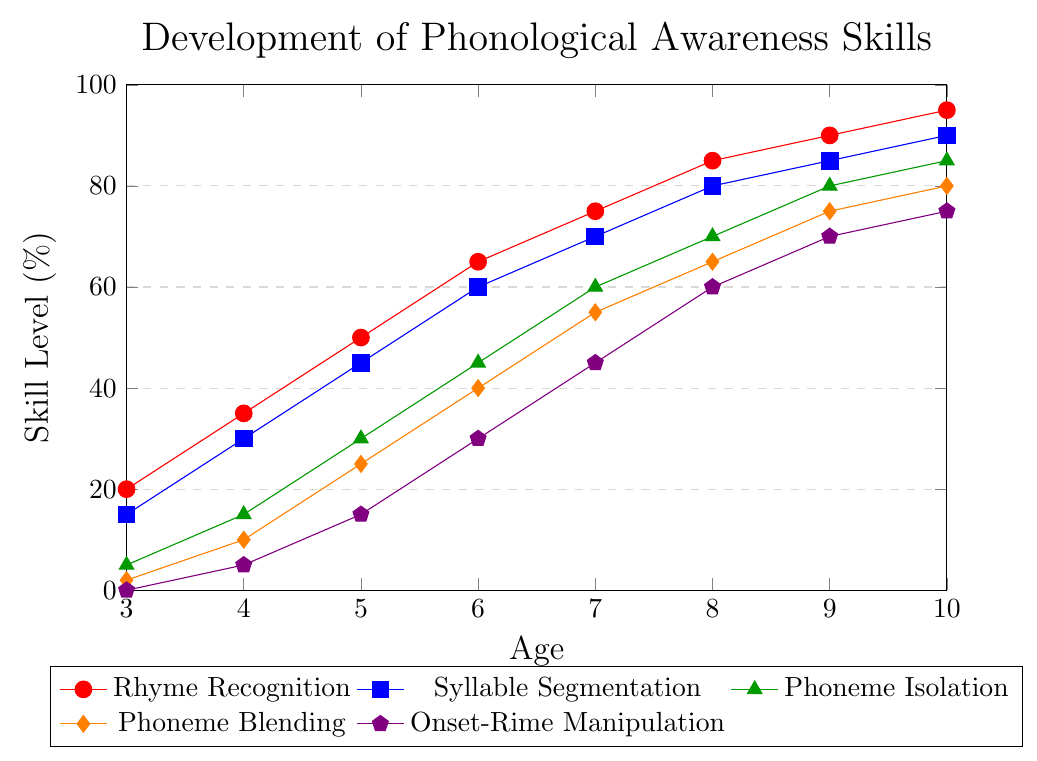What age group shows an 80% skill level for Syllable Segmentation? At age 9, the Syllable Segmentation skill level reaches 85%, but by age 8 it is at 80%. Hence, age 8 is the correct age group.
Answer: 8 Which skill has the lowest percentage at age 3? The data show that Onset-Rime Manipulation has a level of 0% at age 3, which is the lowest among all skills.
Answer: Onset-Rime Manipulation By how much does Phoneme Blending increase from age 4 to age 7? At age 4, the Phoneme Blending level is 10%, and at age 7, it is 55%. The increase is calculated as 55% - 10% = 45%.
Answer: 45% Is the skill level of Phoneme Isolation at age 5 higher than the skill level of Syllable Segmentation at age 4? At age 5, Phoneme Isolation has a skill level of 30% while Syllable Segmentation at age 4 is 30%. Therefore, they are equal.
Answer: No, they are equal What is the average skill level of Rhyme Recognition from ages 6 to 9 inclusive? To find the average, sum the percentages at ages 6, 7, 8, and 9: 65 + 75 + 85 + 90 = 315. Then, divide by the number of ages, which is 4: 315 / 4 = 78.75%.
Answer: 78.75% Among all skill categories, which one reaches 60% first and at what age? Phoneme Isolation reaches 60% at age 7. Other skills reach 60% at age 6 or later.
Answer: Phoneme Isolation at age 7 What is the difference between the skill levels of Rhyme Recognition and Onset-Rime Manipulation at age 10? At age 10, Rhyme Recognition is at 95% and Onset-Rime Manipulation is at 75%. The difference is 95% - 75% = 20%.
Answer: 20% Which skill shows the greatest overall improvement from age 3 to age 10? To find the greatest improvement, subtract the skill level at age 3 from the skill level at age 10 for each category: Rhyme Recognition (95%-20%=75%), Syllable Segmentation (90%-15%=75%), Phoneme Isolation (85%-5%=80%), Phoneme Blending (80%-2%=78%), Onset-Rime Manipulation (75%-0%=75%). Phoneme Isolation has the greatest improvement of 80%.
Answer: Phoneme Isolation 